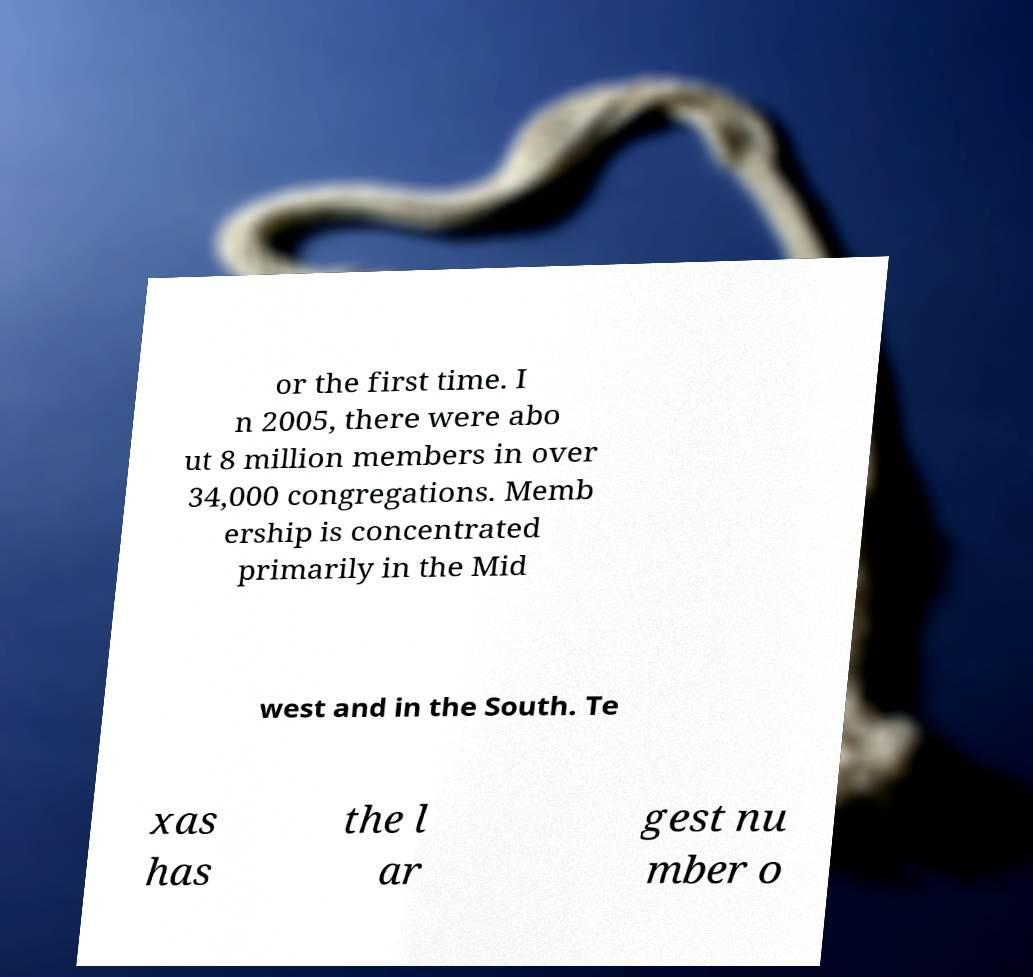For documentation purposes, I need the text within this image transcribed. Could you provide that? or the first time. I n 2005, there were abo ut 8 million members in over 34,000 congregations. Memb ership is concentrated primarily in the Mid west and in the South. Te xas has the l ar gest nu mber o 